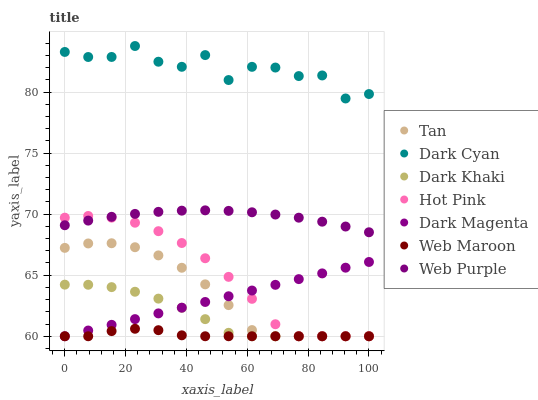Does Web Maroon have the minimum area under the curve?
Answer yes or no. Yes. Does Dark Cyan have the maximum area under the curve?
Answer yes or no. Yes. Does Hot Pink have the minimum area under the curve?
Answer yes or no. No. Does Hot Pink have the maximum area under the curve?
Answer yes or no. No. Is Dark Magenta the smoothest?
Answer yes or no. Yes. Is Dark Cyan the roughest?
Answer yes or no. Yes. Is Hot Pink the smoothest?
Answer yes or no. No. Is Hot Pink the roughest?
Answer yes or no. No. Does Dark Magenta have the lowest value?
Answer yes or no. Yes. Does Web Purple have the lowest value?
Answer yes or no. No. Does Dark Cyan have the highest value?
Answer yes or no. Yes. Does Hot Pink have the highest value?
Answer yes or no. No. Is Dark Khaki less than Web Purple?
Answer yes or no. Yes. Is Dark Cyan greater than Dark Khaki?
Answer yes or no. Yes. Does Hot Pink intersect Dark Khaki?
Answer yes or no. Yes. Is Hot Pink less than Dark Khaki?
Answer yes or no. No. Is Hot Pink greater than Dark Khaki?
Answer yes or no. No. Does Dark Khaki intersect Web Purple?
Answer yes or no. No. 